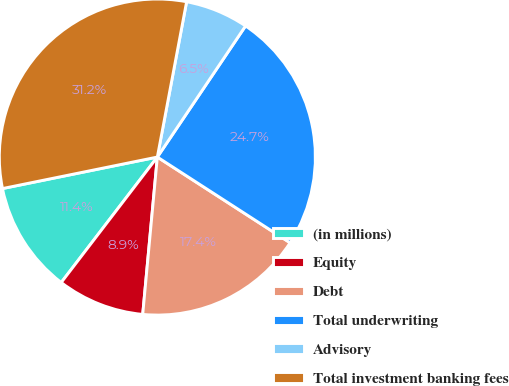Convert chart. <chart><loc_0><loc_0><loc_500><loc_500><pie_chart><fcel>(in millions)<fcel>Equity<fcel>Debt<fcel>Total underwriting<fcel>Advisory<fcel>Total investment banking fees<nl><fcel>11.4%<fcel>8.93%<fcel>17.35%<fcel>24.7%<fcel>6.46%<fcel>31.16%<nl></chart> 